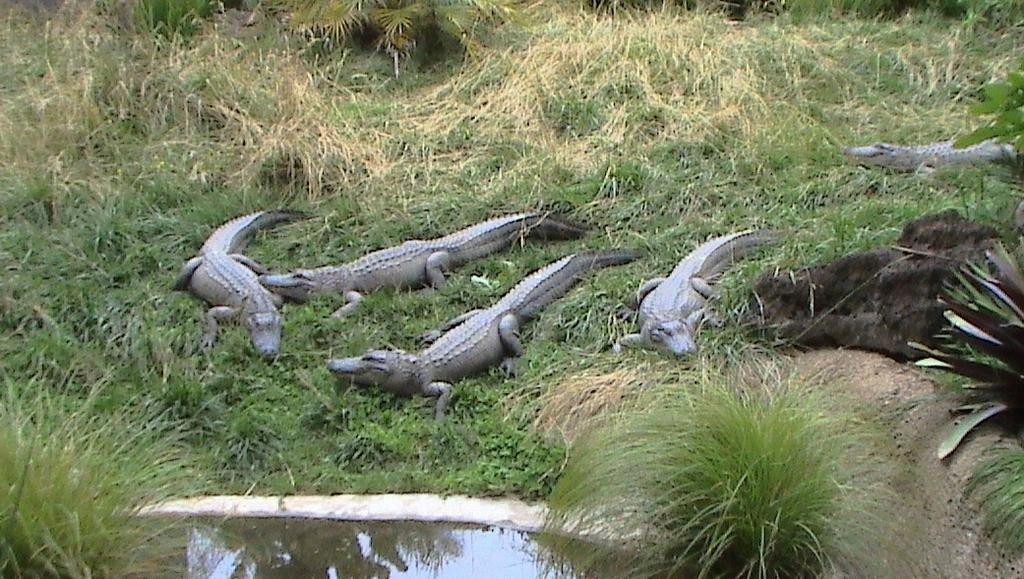Describe this image in one or two sentences. In this picture we can see water at the bottom, there are some plants and grass in the background, we can see alligators in the middle. 